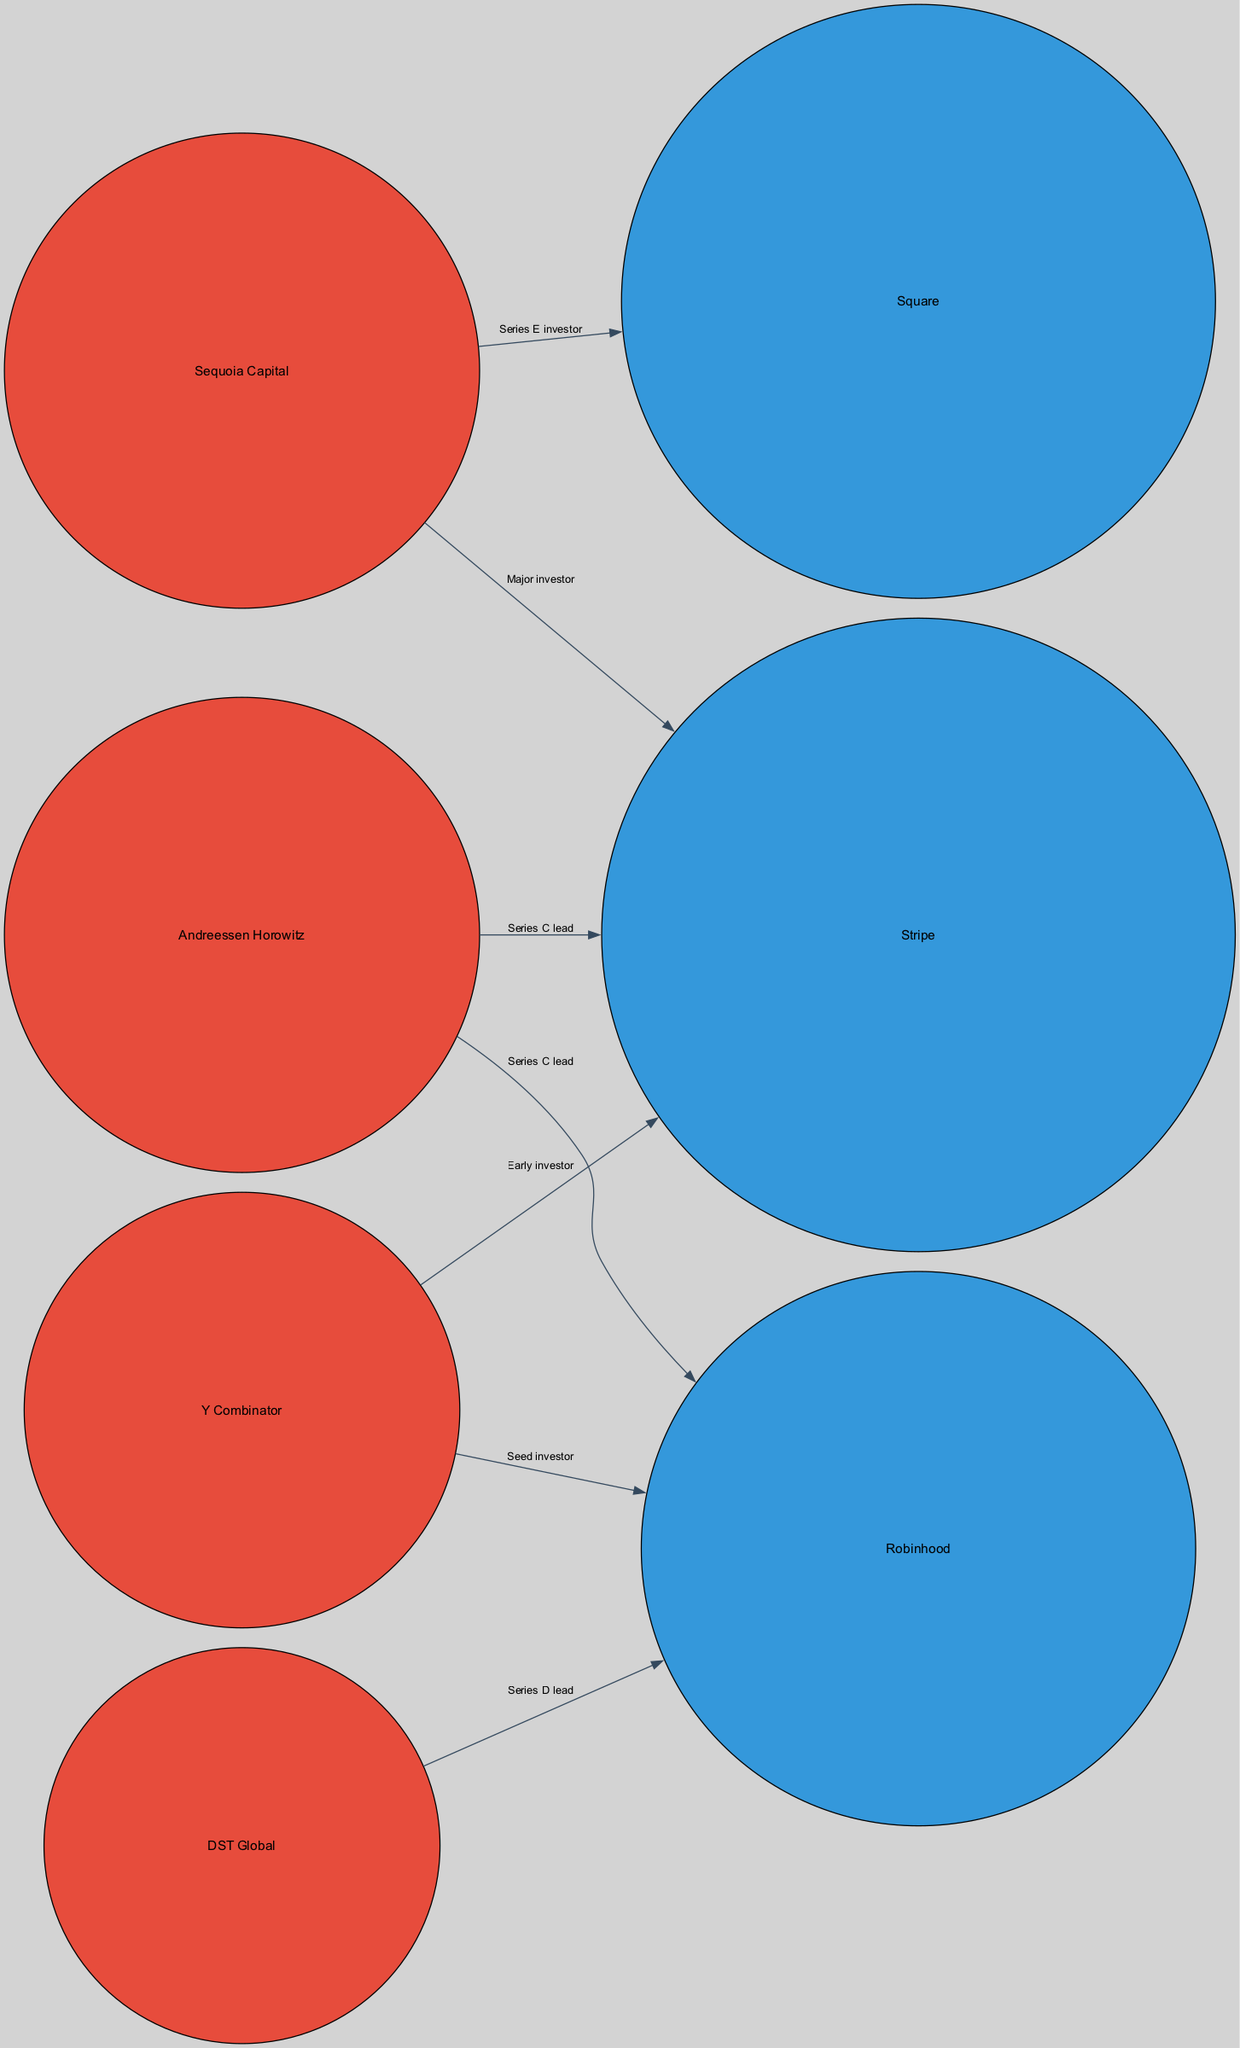What is the total number of companies represented in the diagram? There are three companies listed in the nodes: Stripe, Square, and Robinhood. Therefore, the total number of companies is 3.
Answer: 3 Who is the early investor in Stripe? The edge from Y Combinator to Stripe is labeled "Early investor," indicating Y Combinator is the early investor.
Answer: Y Combinator How many investors are connected to Robinhood? The edges leading to Robinhood show three investors: Andreessen Horowitz, DST Global, and Y Combinator. Therefore, the number of investors connected to Robinhood is 3.
Answer: 3 What type of relationship does Sequoia Capital have with Square? The edge from Sequoia Capital to Square is labeled "Series E investor," which defines the type of relationship between them.
Answer: Series E investor Which company has the largest size representation? Among the companies, Stripe has the largest size representation with a size value of 80, as indicated in the nodes.
Answer: Stripe Which investor has connections to both Stripe and Robinhood? The edge from Andreessen Horowitz connects to both Stripe (as Series C lead) and Robinhood (also as Series C lead), indicating that they have that common connection.
Answer: Andreessen Horowitz How many edges are present in the diagram? By counting the relationships (edges) listed in the data, we identify a total of six edges in the diagram, which represent the connections between companies and investors.
Answer: 6 What color represents the companies in the diagram? Companies are represented using the blue color (#3498db) in the node styling defined in the diagram.
Answer: Blue Which investor is connected to Robinhood as a seed investor? According to the edge from Y Combinator to Robinhood, it is labeled "Seed investor," indicating Y Combinator's connection in that capacity.
Answer: Y Combinator 